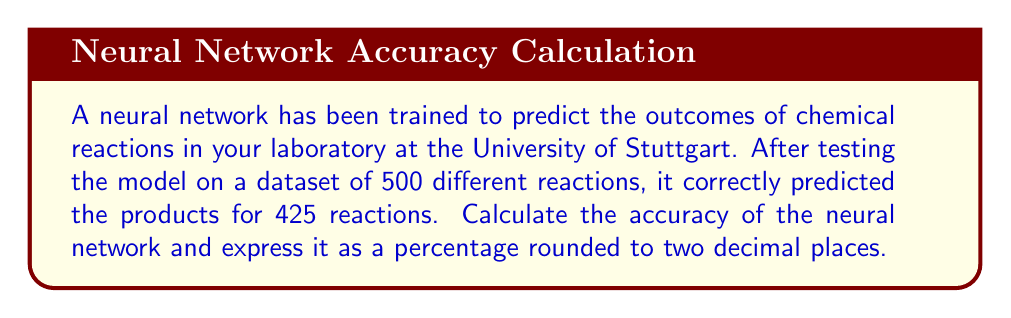Could you help me with this problem? To calculate the accuracy of a neural network, we need to determine the ratio of correct predictions to the total number of predictions made. This ratio is then expressed as a percentage.

Let's break down the problem:

1. Total number of predictions (total reactions tested): 500
2. Number of correct predictions: 425

The formula for accuracy is:

$$ \text{Accuracy} = \frac{\text{Number of Correct Predictions}}{\text{Total Number of Predictions}} \times 100\% $$

Substituting our values:

$$ \text{Accuracy} = \frac{425}{500} \times 100\% $$

To calculate this:

1. Divide 425 by 500:
   $$ \frac{425}{500} = 0.85 $$

2. Multiply by 100 to convert to a percentage:
   $$ 0.85 \times 100\% = 85\% $$

The question asks for the result rounded to two decimal places. Since 85% already has no decimal places, no further rounding is necessary.
Answer: 85.00% 